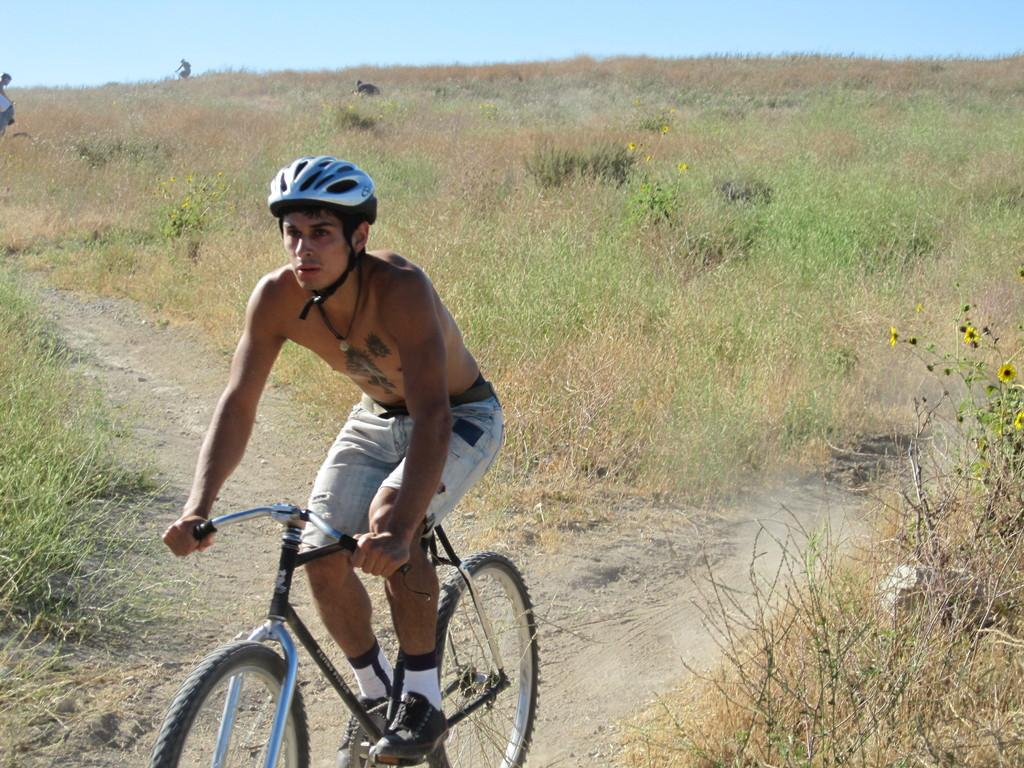What is the main subject of the image? There is a person in the image. What is the person doing in the image? The person is riding a cycle. What safety gear is the person wearing? The person is wearing a helmet. What type of terrain can be seen in the image? There is grass visible in the image. What is the condition of the sky in the image? The sky is clear in the image. Can you tell me how many grapes are on the person's helmet in the image? There are no grapes present on the person's helmet in the image. What type of insect can be seen flying near the person's ear in the image? There is no insect visible near the person's ear in the image. 